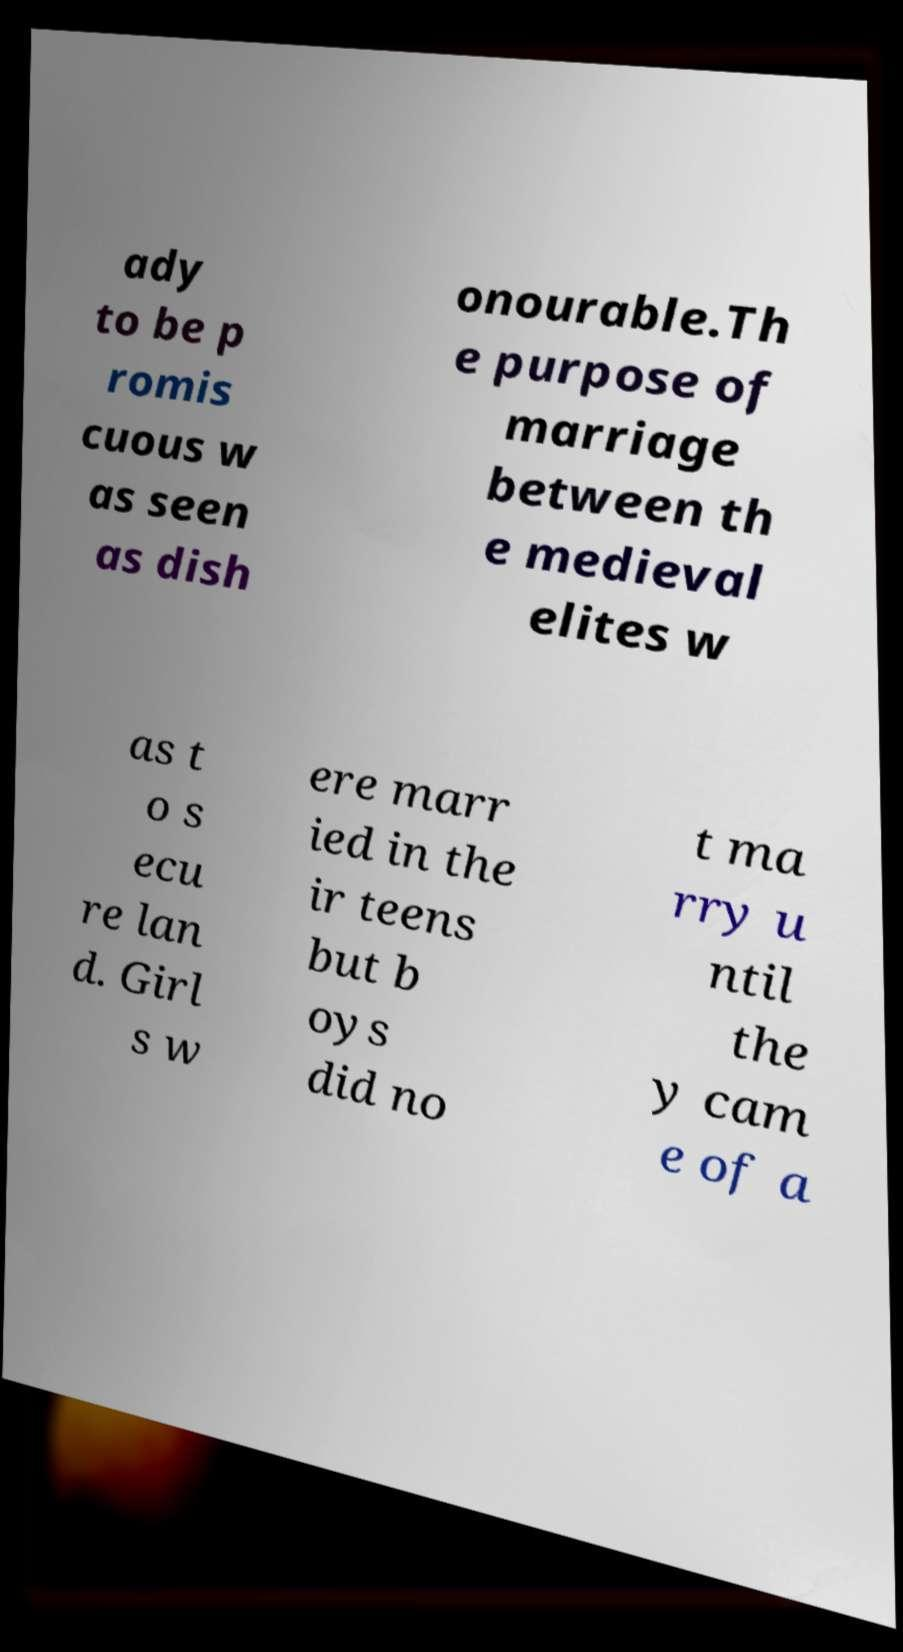I need the written content from this picture converted into text. Can you do that? ady to be p romis cuous w as seen as dish onourable.Th e purpose of marriage between th e medieval elites w as t o s ecu re lan d. Girl s w ere marr ied in the ir teens but b oys did no t ma rry u ntil the y cam e of a 